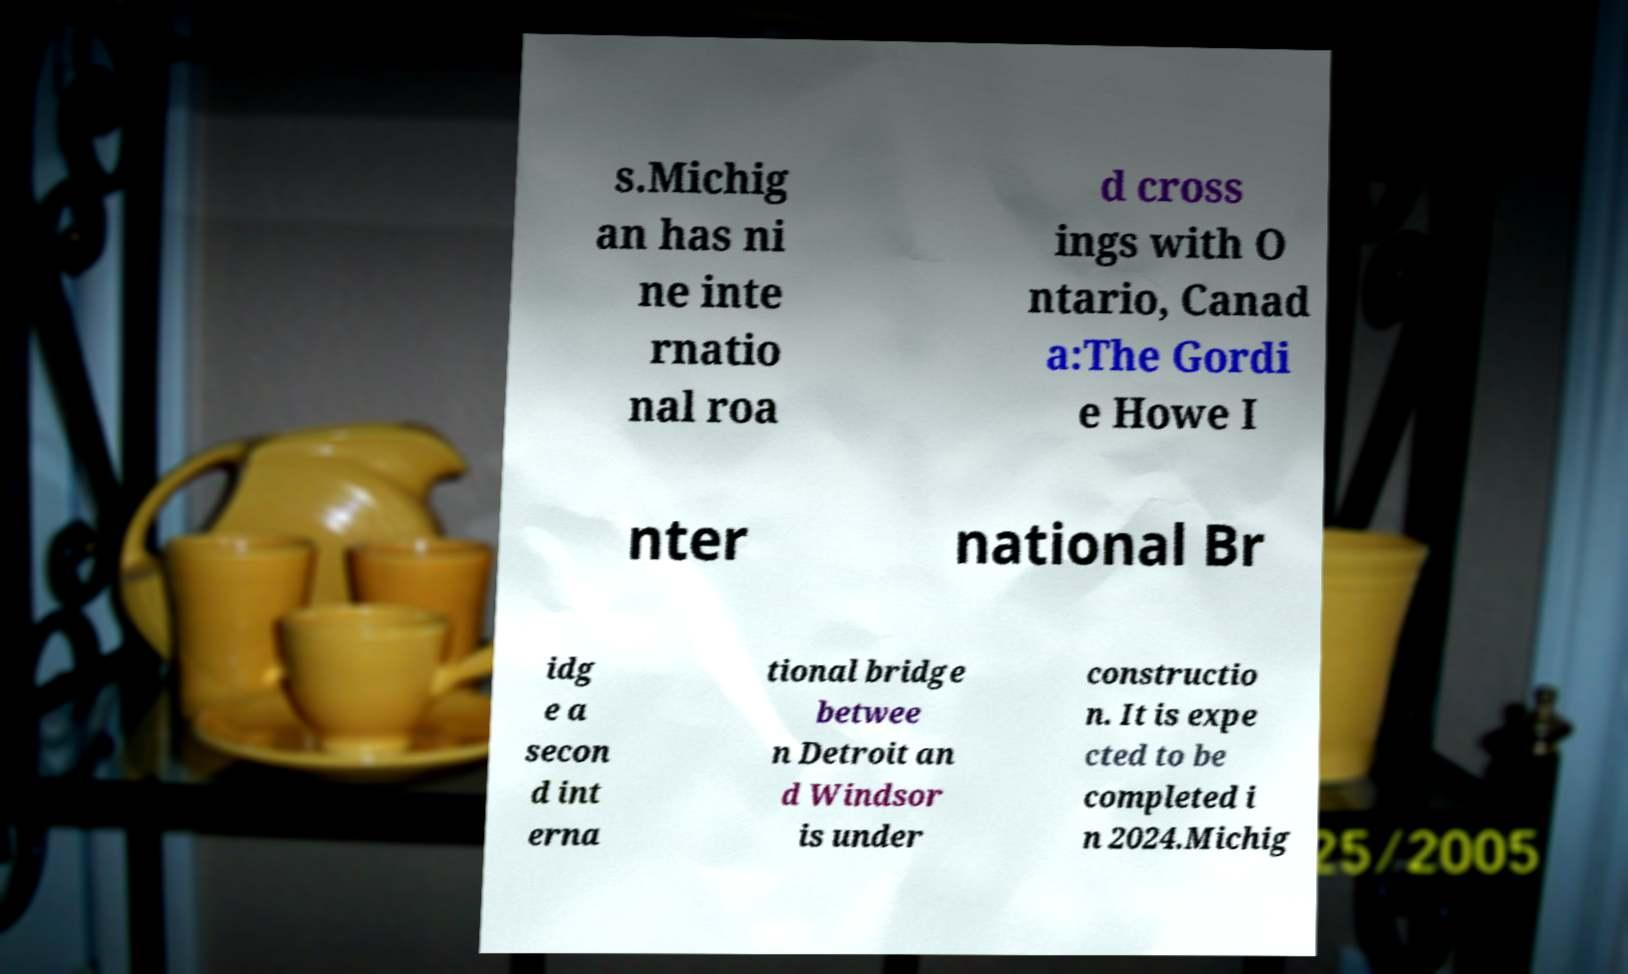Please identify and transcribe the text found in this image. s.Michig an has ni ne inte rnatio nal roa d cross ings with O ntario, Canad a:The Gordi e Howe I nter national Br idg e a secon d int erna tional bridge betwee n Detroit an d Windsor is under constructio n. It is expe cted to be completed i n 2024.Michig 